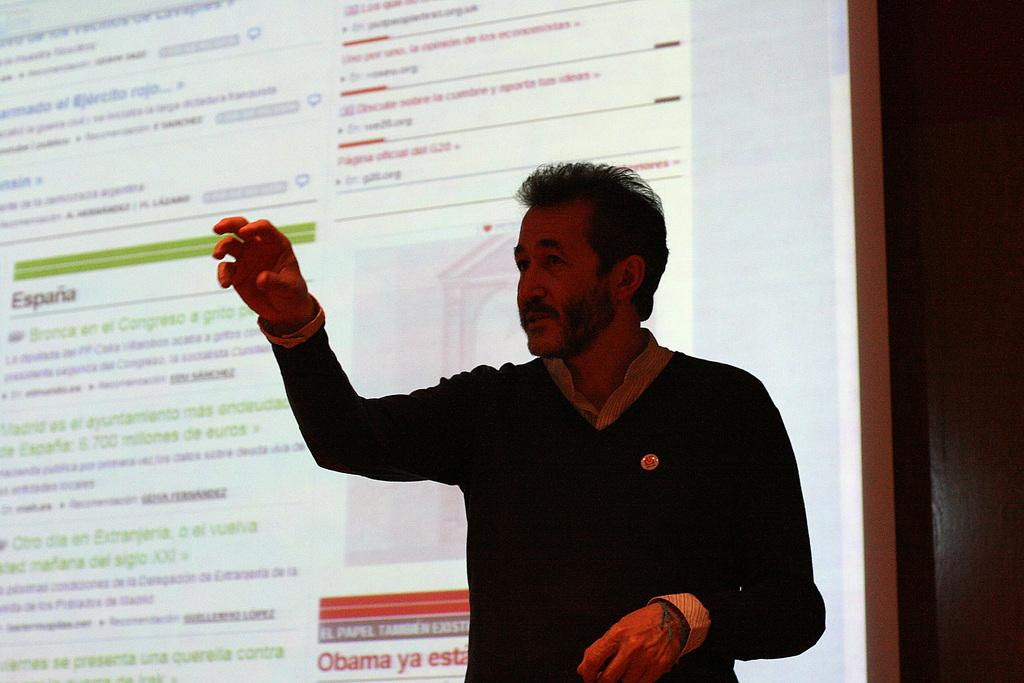What is happening in the image? There is a person in the image who is talking. Can you describe the environment in the image? There is text displayed on a screen in the background. What type of suit is the person wearing in the image? There is no suit visible in the image; the person is not wearing any clothing mentioned in the facts. 